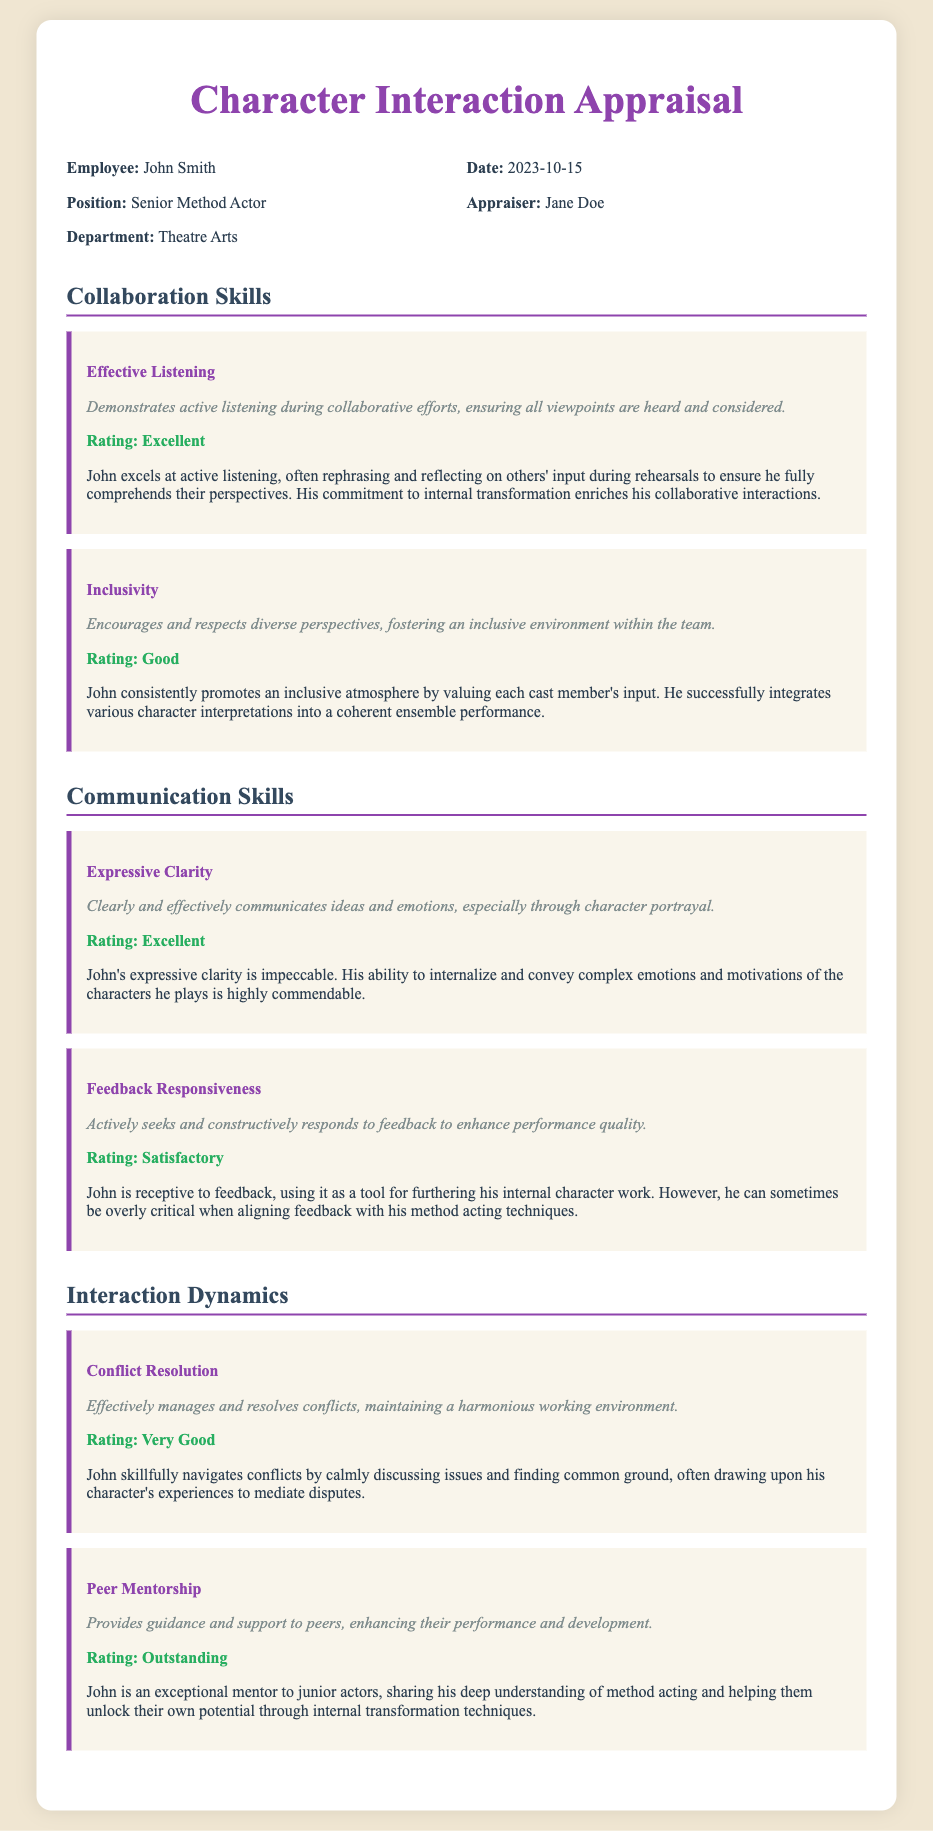what is the name of the employee being appraised? The name is explicitly stated in the document under "Employee".
Answer: John Smith what is the position of John Smith? The position is found in the header section of the document.
Answer: Senior Method Actor who is the appraiser of the document? The appraiser is mentioned in the header alongside the date.
Answer: Jane Doe what date was the appraisal conducted? The date is clearly indicated in the header section.
Answer: 2023-10-15 how is John rated in "Effective Listening"? The rating is specified in the Collaboration Skills section for that criteria.
Answer: Excellent what is the rating for "Feedback Responsiveness"? The rating can be found in the Communication Skills section for that criteria.
Answer: Satisfactory which criteria received an "Outstanding" rating? The rating can be found in the Interaction Dynamics section.
Answer: Peer Mentorship what is the overall theme of the appraisal? The document clearly outlines its focus on specific skills such as collaboration and communication.
Answer: Collaboration and Communication Skills how does John demonstrate inclusivity? This information can be interpreted from the comments provided in the Collaboration Skills section.
Answer: By valuing each cast member's input 